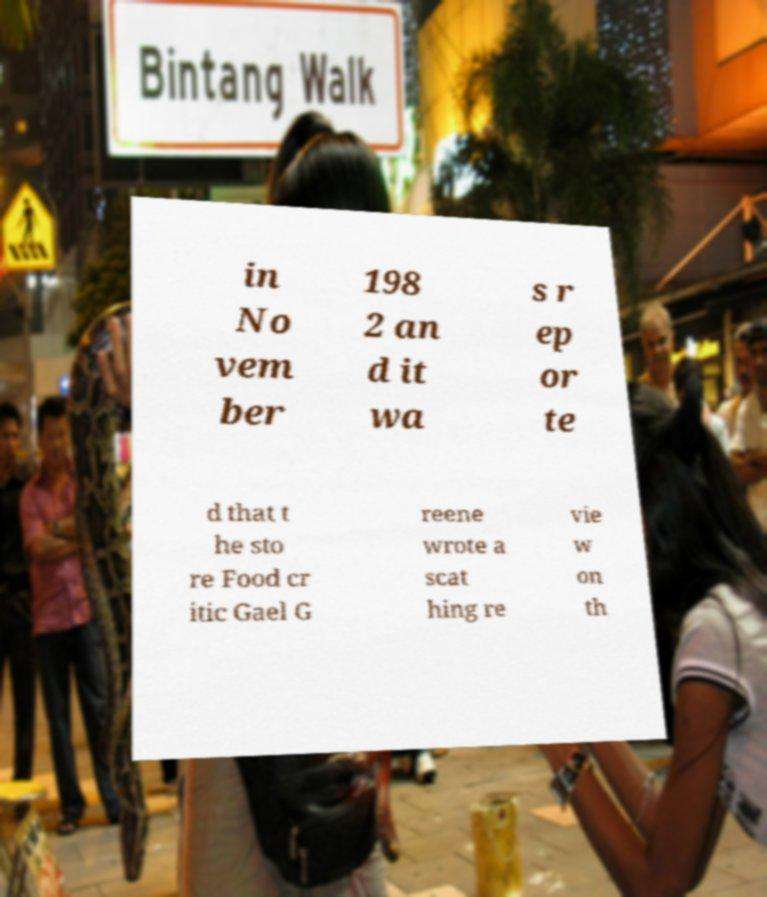Please identify and transcribe the text found in this image. in No vem ber 198 2 an d it wa s r ep or te d that t he sto re Food cr itic Gael G reene wrote a scat hing re vie w on th 